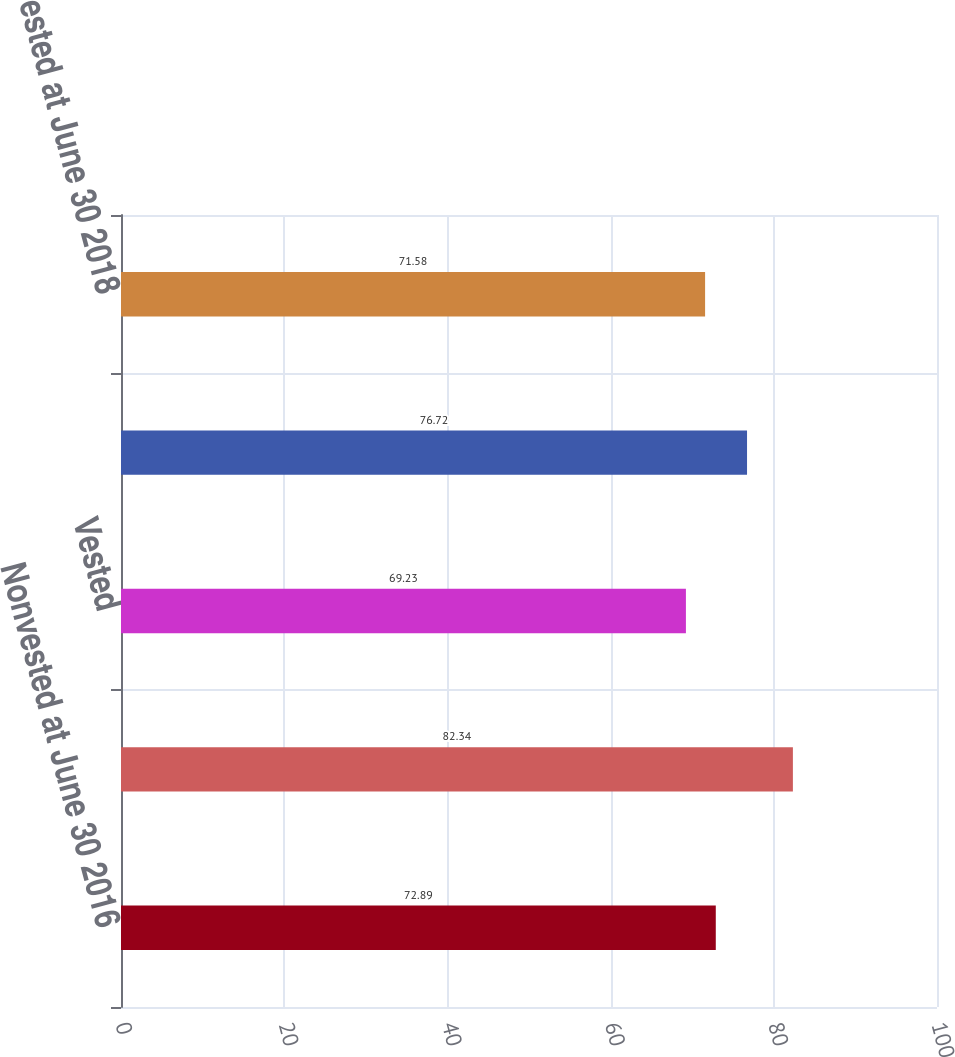<chart> <loc_0><loc_0><loc_500><loc_500><bar_chart><fcel>Nonvested at June 30 2016<fcel>Granted<fcel>Vested<fcel>Nonvested at June 30 2017<fcel>Nonvested at June 30 2018<nl><fcel>72.89<fcel>82.34<fcel>69.23<fcel>76.72<fcel>71.58<nl></chart> 